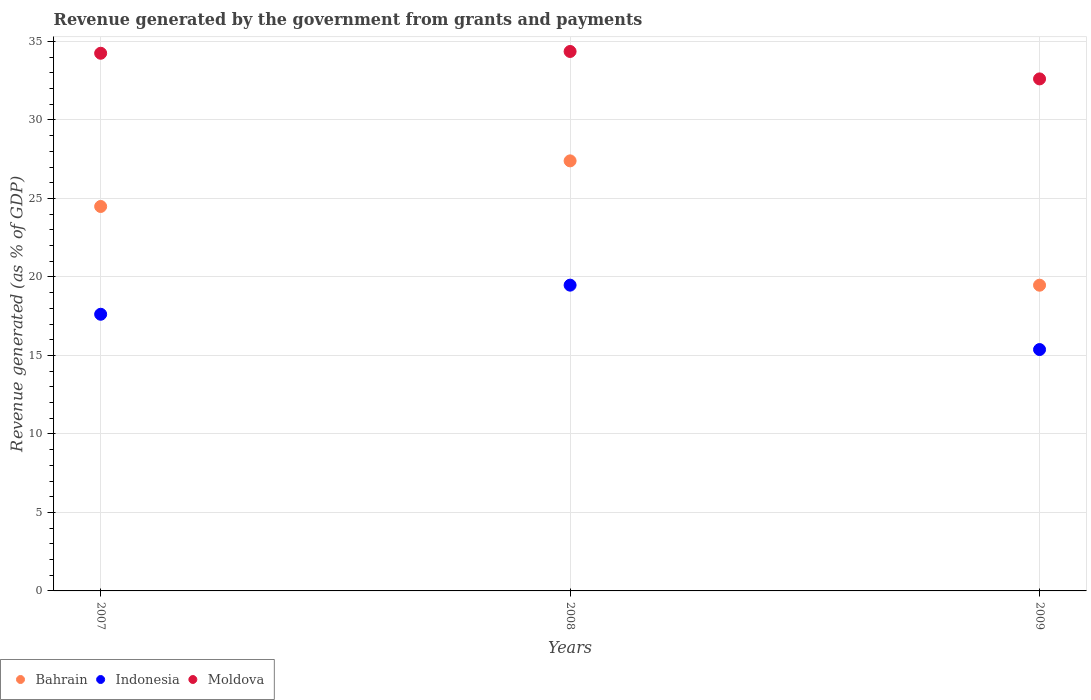What is the revenue generated by the government in Indonesia in 2009?
Offer a terse response. 15.38. Across all years, what is the maximum revenue generated by the government in Indonesia?
Ensure brevity in your answer.  19.48. Across all years, what is the minimum revenue generated by the government in Bahrain?
Your answer should be compact. 19.47. What is the total revenue generated by the government in Bahrain in the graph?
Your response must be concise. 71.36. What is the difference between the revenue generated by the government in Bahrain in 2007 and that in 2009?
Your response must be concise. 5.01. What is the difference between the revenue generated by the government in Moldova in 2009 and the revenue generated by the government in Indonesia in 2007?
Offer a terse response. 14.99. What is the average revenue generated by the government in Bahrain per year?
Give a very brief answer. 23.79. In the year 2008, what is the difference between the revenue generated by the government in Indonesia and revenue generated by the government in Bahrain?
Provide a short and direct response. -7.92. In how many years, is the revenue generated by the government in Bahrain greater than 28 %?
Ensure brevity in your answer.  0. What is the ratio of the revenue generated by the government in Moldova in 2008 to that in 2009?
Your response must be concise. 1.05. Is the difference between the revenue generated by the government in Indonesia in 2008 and 2009 greater than the difference between the revenue generated by the government in Bahrain in 2008 and 2009?
Provide a succinct answer. No. What is the difference between the highest and the second highest revenue generated by the government in Bahrain?
Provide a short and direct response. 2.91. What is the difference between the highest and the lowest revenue generated by the government in Bahrain?
Make the answer very short. 7.92. Is the sum of the revenue generated by the government in Indonesia in 2007 and 2009 greater than the maximum revenue generated by the government in Bahrain across all years?
Your answer should be compact. Yes. Does the revenue generated by the government in Bahrain monotonically increase over the years?
Offer a terse response. No. Is the revenue generated by the government in Bahrain strictly less than the revenue generated by the government in Moldova over the years?
Your answer should be compact. Yes. How many dotlines are there?
Give a very brief answer. 3. How many years are there in the graph?
Keep it short and to the point. 3. What is the difference between two consecutive major ticks on the Y-axis?
Offer a terse response. 5. Does the graph contain any zero values?
Offer a terse response. No. Where does the legend appear in the graph?
Keep it short and to the point. Bottom left. How many legend labels are there?
Your answer should be very brief. 3. What is the title of the graph?
Ensure brevity in your answer.  Revenue generated by the government from grants and payments. What is the label or title of the X-axis?
Give a very brief answer. Years. What is the label or title of the Y-axis?
Keep it short and to the point. Revenue generated (as % of GDP). What is the Revenue generated (as % of GDP) in Bahrain in 2007?
Give a very brief answer. 24.49. What is the Revenue generated (as % of GDP) of Indonesia in 2007?
Give a very brief answer. 17.62. What is the Revenue generated (as % of GDP) of Moldova in 2007?
Make the answer very short. 34.25. What is the Revenue generated (as % of GDP) in Bahrain in 2008?
Make the answer very short. 27.39. What is the Revenue generated (as % of GDP) of Indonesia in 2008?
Provide a succinct answer. 19.48. What is the Revenue generated (as % of GDP) in Moldova in 2008?
Ensure brevity in your answer.  34.36. What is the Revenue generated (as % of GDP) in Bahrain in 2009?
Offer a terse response. 19.47. What is the Revenue generated (as % of GDP) of Indonesia in 2009?
Your answer should be very brief. 15.38. What is the Revenue generated (as % of GDP) in Moldova in 2009?
Make the answer very short. 32.61. Across all years, what is the maximum Revenue generated (as % of GDP) of Bahrain?
Ensure brevity in your answer.  27.39. Across all years, what is the maximum Revenue generated (as % of GDP) of Indonesia?
Your response must be concise. 19.48. Across all years, what is the maximum Revenue generated (as % of GDP) in Moldova?
Offer a terse response. 34.36. Across all years, what is the minimum Revenue generated (as % of GDP) of Bahrain?
Keep it short and to the point. 19.47. Across all years, what is the minimum Revenue generated (as % of GDP) in Indonesia?
Give a very brief answer. 15.38. Across all years, what is the minimum Revenue generated (as % of GDP) in Moldova?
Keep it short and to the point. 32.61. What is the total Revenue generated (as % of GDP) in Bahrain in the graph?
Offer a very short reply. 71.36. What is the total Revenue generated (as % of GDP) in Indonesia in the graph?
Keep it short and to the point. 52.47. What is the total Revenue generated (as % of GDP) of Moldova in the graph?
Provide a succinct answer. 101.22. What is the difference between the Revenue generated (as % of GDP) of Bahrain in 2007 and that in 2008?
Provide a short and direct response. -2.91. What is the difference between the Revenue generated (as % of GDP) of Indonesia in 2007 and that in 2008?
Keep it short and to the point. -1.85. What is the difference between the Revenue generated (as % of GDP) of Moldova in 2007 and that in 2008?
Offer a very short reply. -0.11. What is the difference between the Revenue generated (as % of GDP) of Bahrain in 2007 and that in 2009?
Provide a short and direct response. 5.01. What is the difference between the Revenue generated (as % of GDP) of Indonesia in 2007 and that in 2009?
Your answer should be very brief. 2.25. What is the difference between the Revenue generated (as % of GDP) in Moldova in 2007 and that in 2009?
Make the answer very short. 1.63. What is the difference between the Revenue generated (as % of GDP) of Bahrain in 2008 and that in 2009?
Your answer should be very brief. 7.92. What is the difference between the Revenue generated (as % of GDP) in Indonesia in 2008 and that in 2009?
Your answer should be very brief. 4.1. What is the difference between the Revenue generated (as % of GDP) of Moldova in 2008 and that in 2009?
Your response must be concise. 1.75. What is the difference between the Revenue generated (as % of GDP) in Bahrain in 2007 and the Revenue generated (as % of GDP) in Indonesia in 2008?
Make the answer very short. 5.01. What is the difference between the Revenue generated (as % of GDP) in Bahrain in 2007 and the Revenue generated (as % of GDP) in Moldova in 2008?
Make the answer very short. -9.87. What is the difference between the Revenue generated (as % of GDP) of Indonesia in 2007 and the Revenue generated (as % of GDP) of Moldova in 2008?
Keep it short and to the point. -16.74. What is the difference between the Revenue generated (as % of GDP) in Bahrain in 2007 and the Revenue generated (as % of GDP) in Indonesia in 2009?
Offer a terse response. 9.11. What is the difference between the Revenue generated (as % of GDP) in Bahrain in 2007 and the Revenue generated (as % of GDP) in Moldova in 2009?
Keep it short and to the point. -8.13. What is the difference between the Revenue generated (as % of GDP) of Indonesia in 2007 and the Revenue generated (as % of GDP) of Moldova in 2009?
Provide a short and direct response. -14.99. What is the difference between the Revenue generated (as % of GDP) in Bahrain in 2008 and the Revenue generated (as % of GDP) in Indonesia in 2009?
Offer a very short reply. 12.02. What is the difference between the Revenue generated (as % of GDP) of Bahrain in 2008 and the Revenue generated (as % of GDP) of Moldova in 2009?
Your answer should be compact. -5.22. What is the difference between the Revenue generated (as % of GDP) in Indonesia in 2008 and the Revenue generated (as % of GDP) in Moldova in 2009?
Your answer should be very brief. -13.14. What is the average Revenue generated (as % of GDP) in Bahrain per year?
Offer a very short reply. 23.79. What is the average Revenue generated (as % of GDP) of Indonesia per year?
Offer a very short reply. 17.49. What is the average Revenue generated (as % of GDP) of Moldova per year?
Keep it short and to the point. 33.74. In the year 2007, what is the difference between the Revenue generated (as % of GDP) of Bahrain and Revenue generated (as % of GDP) of Indonesia?
Provide a succinct answer. 6.87. In the year 2007, what is the difference between the Revenue generated (as % of GDP) in Bahrain and Revenue generated (as % of GDP) in Moldova?
Make the answer very short. -9.76. In the year 2007, what is the difference between the Revenue generated (as % of GDP) of Indonesia and Revenue generated (as % of GDP) of Moldova?
Your answer should be compact. -16.63. In the year 2008, what is the difference between the Revenue generated (as % of GDP) in Bahrain and Revenue generated (as % of GDP) in Indonesia?
Offer a very short reply. 7.92. In the year 2008, what is the difference between the Revenue generated (as % of GDP) of Bahrain and Revenue generated (as % of GDP) of Moldova?
Offer a very short reply. -6.97. In the year 2008, what is the difference between the Revenue generated (as % of GDP) in Indonesia and Revenue generated (as % of GDP) in Moldova?
Your answer should be compact. -14.88. In the year 2009, what is the difference between the Revenue generated (as % of GDP) in Bahrain and Revenue generated (as % of GDP) in Indonesia?
Ensure brevity in your answer.  4.1. In the year 2009, what is the difference between the Revenue generated (as % of GDP) of Bahrain and Revenue generated (as % of GDP) of Moldova?
Provide a short and direct response. -13.14. In the year 2009, what is the difference between the Revenue generated (as % of GDP) of Indonesia and Revenue generated (as % of GDP) of Moldova?
Offer a terse response. -17.24. What is the ratio of the Revenue generated (as % of GDP) in Bahrain in 2007 to that in 2008?
Ensure brevity in your answer.  0.89. What is the ratio of the Revenue generated (as % of GDP) in Indonesia in 2007 to that in 2008?
Offer a terse response. 0.9. What is the ratio of the Revenue generated (as % of GDP) of Bahrain in 2007 to that in 2009?
Ensure brevity in your answer.  1.26. What is the ratio of the Revenue generated (as % of GDP) in Indonesia in 2007 to that in 2009?
Make the answer very short. 1.15. What is the ratio of the Revenue generated (as % of GDP) of Moldova in 2007 to that in 2009?
Offer a terse response. 1.05. What is the ratio of the Revenue generated (as % of GDP) in Bahrain in 2008 to that in 2009?
Offer a terse response. 1.41. What is the ratio of the Revenue generated (as % of GDP) of Indonesia in 2008 to that in 2009?
Make the answer very short. 1.27. What is the ratio of the Revenue generated (as % of GDP) of Moldova in 2008 to that in 2009?
Offer a terse response. 1.05. What is the difference between the highest and the second highest Revenue generated (as % of GDP) in Bahrain?
Make the answer very short. 2.91. What is the difference between the highest and the second highest Revenue generated (as % of GDP) in Indonesia?
Your response must be concise. 1.85. What is the difference between the highest and the second highest Revenue generated (as % of GDP) of Moldova?
Provide a short and direct response. 0.11. What is the difference between the highest and the lowest Revenue generated (as % of GDP) in Bahrain?
Keep it short and to the point. 7.92. What is the difference between the highest and the lowest Revenue generated (as % of GDP) in Indonesia?
Provide a short and direct response. 4.1. What is the difference between the highest and the lowest Revenue generated (as % of GDP) of Moldova?
Keep it short and to the point. 1.75. 